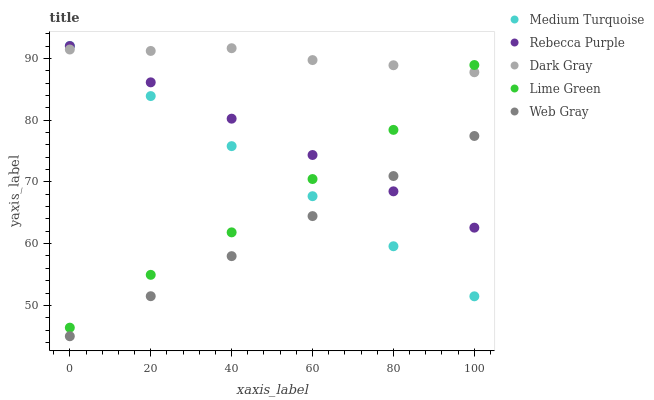Does Web Gray have the minimum area under the curve?
Answer yes or no. Yes. Does Dark Gray have the maximum area under the curve?
Answer yes or no. Yes. Does Lime Green have the minimum area under the curve?
Answer yes or no. No. Does Lime Green have the maximum area under the curve?
Answer yes or no. No. Is Web Gray the smoothest?
Answer yes or no. Yes. Is Lime Green the roughest?
Answer yes or no. Yes. Is Lime Green the smoothest?
Answer yes or no. No. Is Web Gray the roughest?
Answer yes or no. No. Does Web Gray have the lowest value?
Answer yes or no. Yes. Does Lime Green have the lowest value?
Answer yes or no. No. Does Medium Turquoise have the highest value?
Answer yes or no. Yes. Does Lime Green have the highest value?
Answer yes or no. No. Is Web Gray less than Dark Gray?
Answer yes or no. Yes. Is Dark Gray greater than Web Gray?
Answer yes or no. Yes. Does Dark Gray intersect Rebecca Purple?
Answer yes or no. Yes. Is Dark Gray less than Rebecca Purple?
Answer yes or no. No. Is Dark Gray greater than Rebecca Purple?
Answer yes or no. No. Does Web Gray intersect Dark Gray?
Answer yes or no. No. 